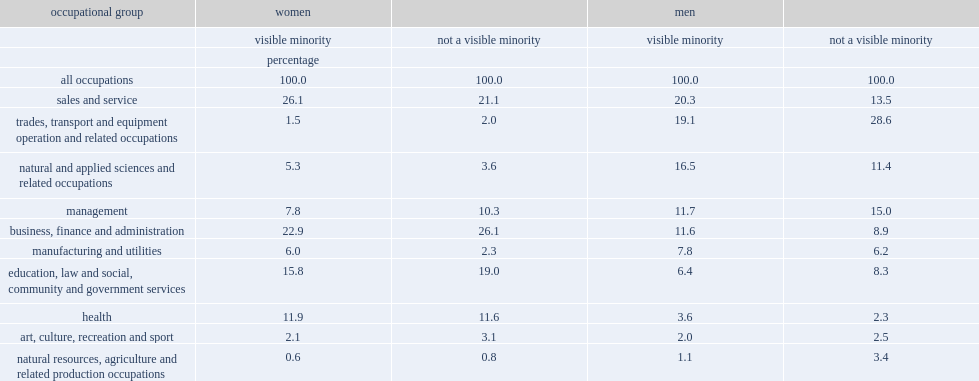Which group of women of core working age were somewhat less likely to be employed in management? Visible minority. Which group of women were more likely to be employed in manufacturing and utilities, visible minority or not a visible minority? Visible minority. Which group of women were more likely to be employed in natural and applied sciences, visible minority or not a visible minority? Visible minority. What was the percentage of the most commonly reported occupation for visible minority men of core working age in sales and service? 20.3. What was the percentage of same-aged men who did not belong to a visible minority group were employed in sales and service occupations? 13.5. 